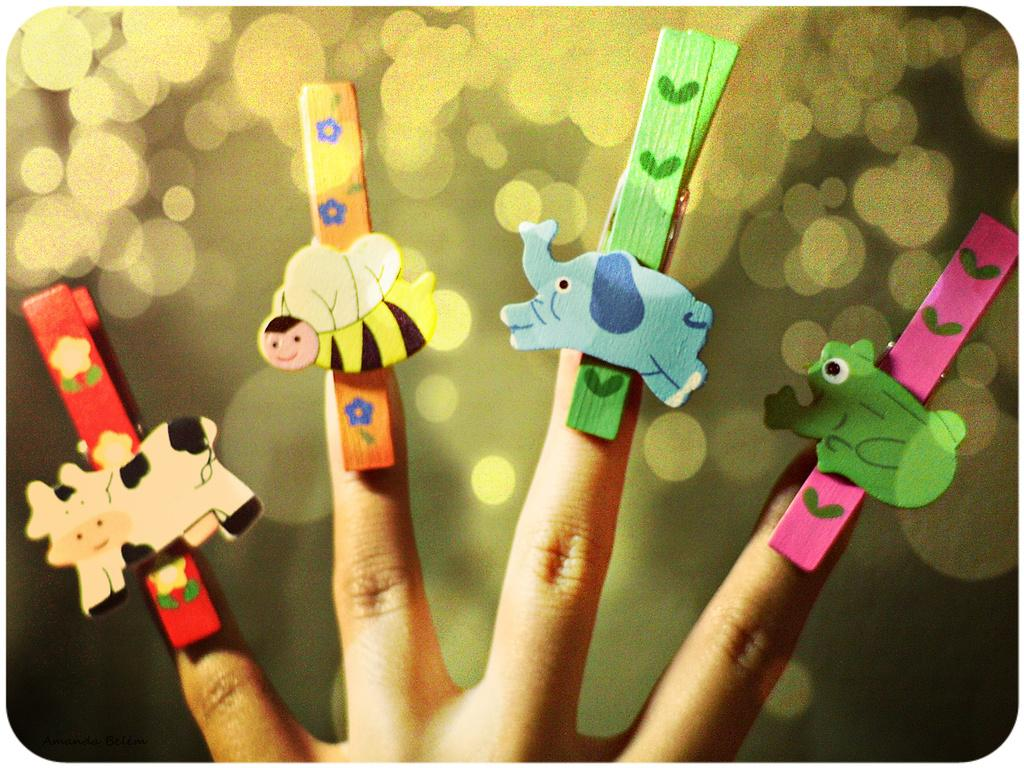What part of a person is visible in the image? There are fingers of a person in the image. What is attached to the fingers in the image? There are objects attached to the fingers. What type of kettle can be seen in harmony with the elbow in the image? There is no kettle or elbow present in the image; it only features fingers with objects attached to them. 